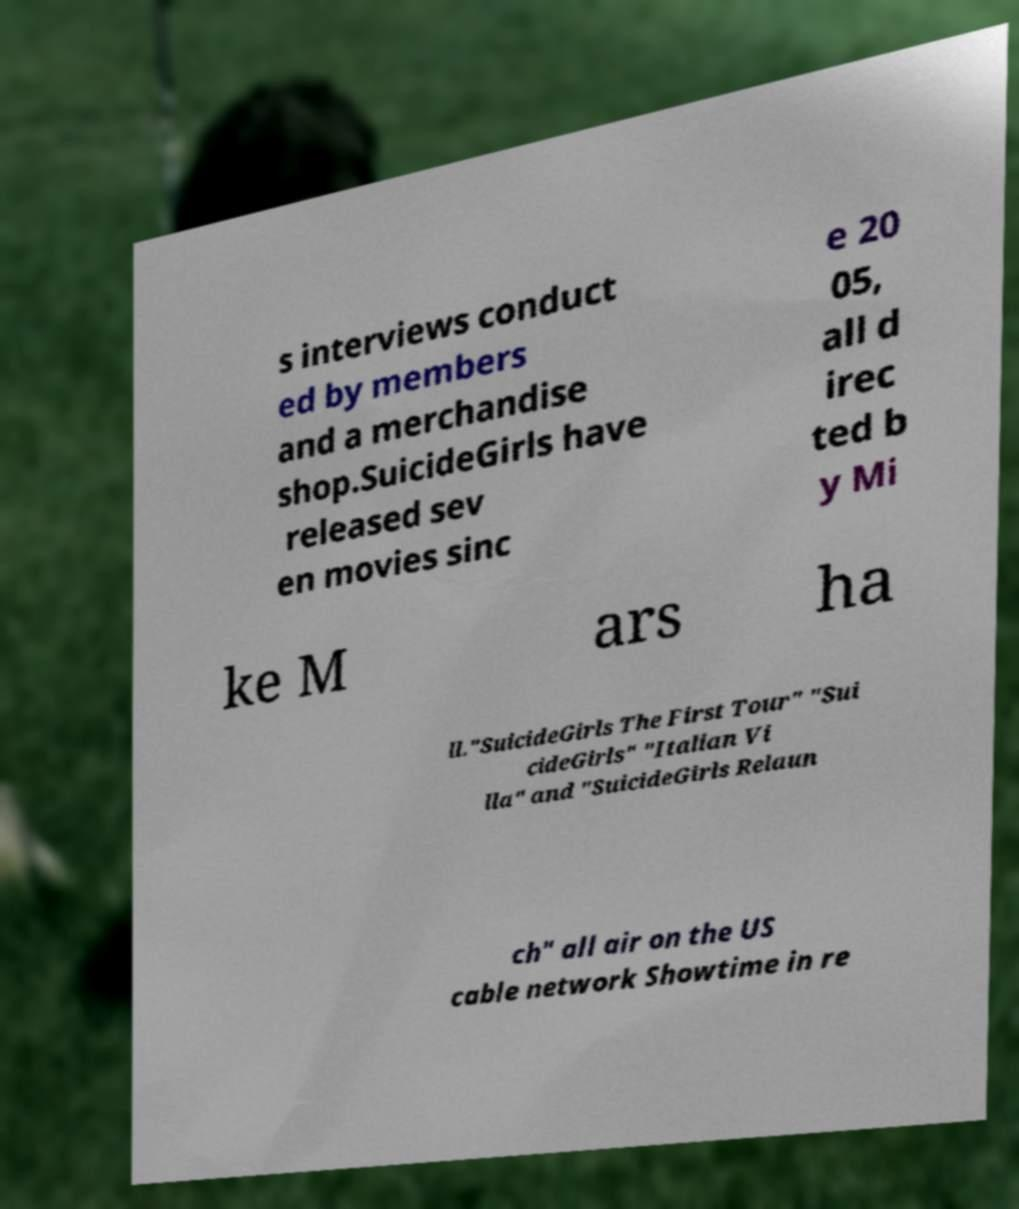Could you extract and type out the text from this image? s interviews conduct ed by members and a merchandise shop.SuicideGirls have released sev en movies sinc e 20 05, all d irec ted b y Mi ke M ars ha ll."SuicideGirls The First Tour" "Sui cideGirls" "Italian Vi lla" and "SuicideGirls Relaun ch" all air on the US cable network Showtime in re 